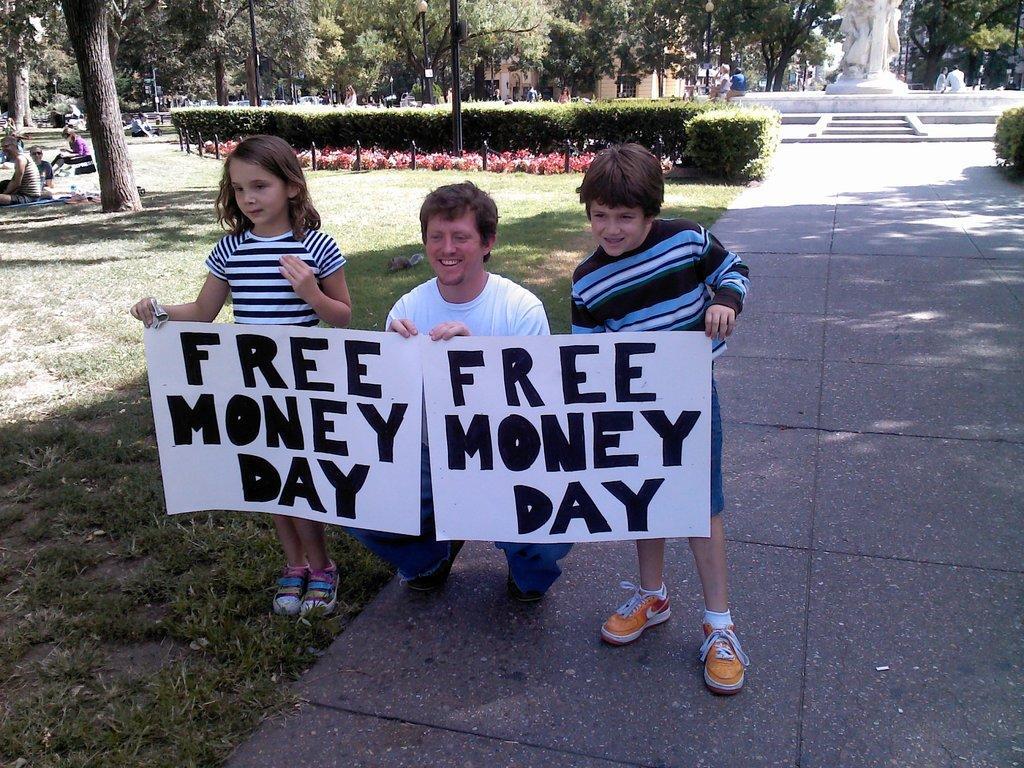Could you give a brief overview of what you see in this image? In this picture there are persons sitting, standing and squatting. In the front there are three persons smiling and holding a banner with some text written on it. In the background there is grass on the ground and there are plants, trees and there is a statue which is white in colour. 